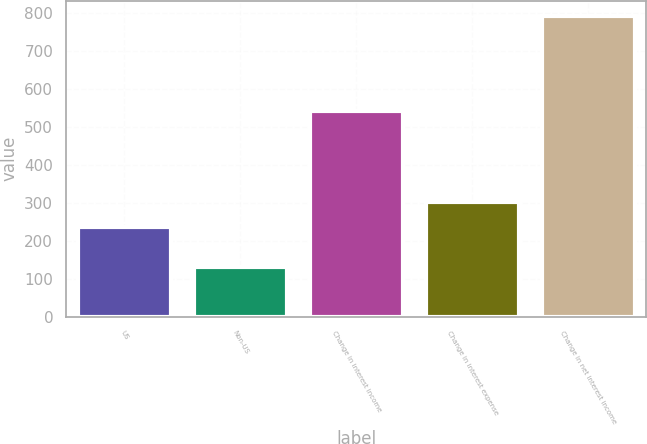<chart> <loc_0><loc_0><loc_500><loc_500><bar_chart><fcel>US<fcel>Non-US<fcel>Change in interest income<fcel>Change in interest expense<fcel>Change in net interest income<nl><fcel>237<fcel>130<fcel>542<fcel>303.2<fcel>792<nl></chart> 